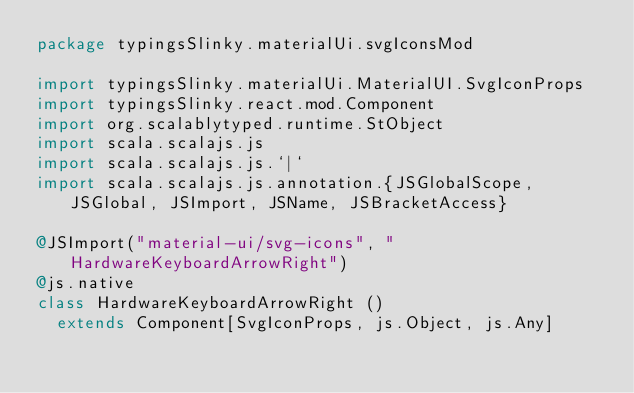<code> <loc_0><loc_0><loc_500><loc_500><_Scala_>package typingsSlinky.materialUi.svgIconsMod

import typingsSlinky.materialUi.MaterialUI.SvgIconProps
import typingsSlinky.react.mod.Component
import org.scalablytyped.runtime.StObject
import scala.scalajs.js
import scala.scalajs.js.`|`
import scala.scalajs.js.annotation.{JSGlobalScope, JSGlobal, JSImport, JSName, JSBracketAccess}

@JSImport("material-ui/svg-icons", "HardwareKeyboardArrowRight")
@js.native
class HardwareKeyboardArrowRight ()
  extends Component[SvgIconProps, js.Object, js.Any]
</code> 